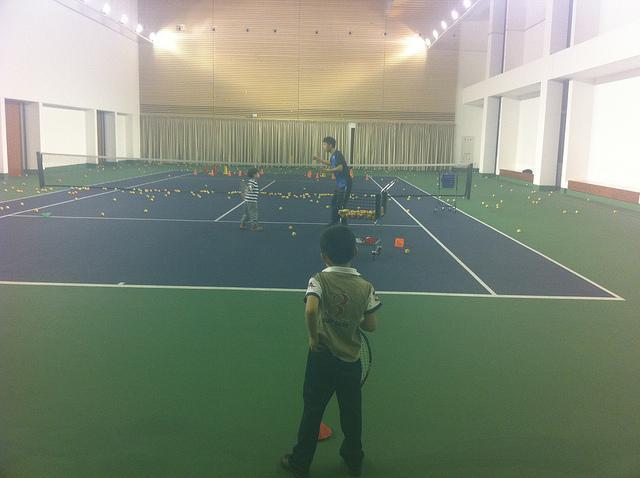How many players are on the field?
Give a very brief answer. 3. How many surfboards do you see?
Give a very brief answer. 0. 